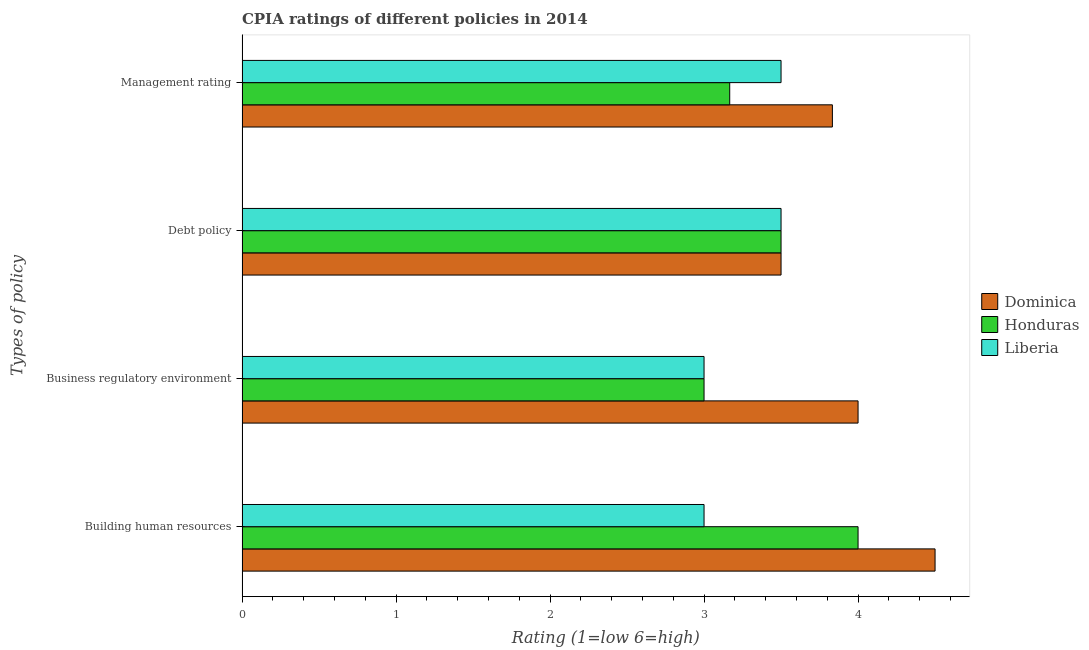Are the number of bars per tick equal to the number of legend labels?
Provide a short and direct response. Yes. Are the number of bars on each tick of the Y-axis equal?
Your answer should be compact. Yes. How many bars are there on the 4th tick from the top?
Your answer should be compact. 3. What is the label of the 1st group of bars from the top?
Offer a terse response. Management rating. Across all countries, what is the minimum cpia rating of management?
Keep it short and to the point. 3.17. In which country was the cpia rating of debt policy maximum?
Make the answer very short. Dominica. In which country was the cpia rating of building human resources minimum?
Provide a succinct answer. Liberia. What is the total cpia rating of building human resources in the graph?
Offer a very short reply. 11.5. What is the average cpia rating of business regulatory environment per country?
Your answer should be very brief. 3.33. What is the difference between the cpia rating of debt policy and cpia rating of business regulatory environment in Honduras?
Give a very brief answer. 0.5. Is the cpia rating of management in Dominica less than that in Honduras?
Keep it short and to the point. No. Is the difference between the cpia rating of building human resources in Dominica and Liberia greater than the difference between the cpia rating of business regulatory environment in Dominica and Liberia?
Provide a short and direct response. Yes. What is the difference between the highest and the lowest cpia rating of debt policy?
Offer a very short reply. 0. In how many countries, is the cpia rating of debt policy greater than the average cpia rating of debt policy taken over all countries?
Provide a succinct answer. 0. What does the 1st bar from the top in Debt policy represents?
Provide a succinct answer. Liberia. What does the 1st bar from the bottom in Business regulatory environment represents?
Ensure brevity in your answer.  Dominica. Is it the case that in every country, the sum of the cpia rating of building human resources and cpia rating of business regulatory environment is greater than the cpia rating of debt policy?
Offer a very short reply. Yes. How many bars are there?
Keep it short and to the point. 12. How many countries are there in the graph?
Offer a terse response. 3. What is the difference between two consecutive major ticks on the X-axis?
Give a very brief answer. 1. Are the values on the major ticks of X-axis written in scientific E-notation?
Your answer should be compact. No. Where does the legend appear in the graph?
Offer a very short reply. Center right. How are the legend labels stacked?
Offer a very short reply. Vertical. What is the title of the graph?
Your answer should be compact. CPIA ratings of different policies in 2014. Does "Angola" appear as one of the legend labels in the graph?
Keep it short and to the point. No. What is the label or title of the X-axis?
Provide a short and direct response. Rating (1=low 6=high). What is the label or title of the Y-axis?
Offer a very short reply. Types of policy. What is the Rating (1=low 6=high) of Honduras in Building human resources?
Provide a succinct answer. 4. What is the Rating (1=low 6=high) in Liberia in Building human resources?
Your answer should be compact. 3. What is the Rating (1=low 6=high) of Dominica in Business regulatory environment?
Keep it short and to the point. 4. What is the Rating (1=low 6=high) of Honduras in Business regulatory environment?
Give a very brief answer. 3. What is the Rating (1=low 6=high) in Dominica in Debt policy?
Offer a terse response. 3.5. What is the Rating (1=low 6=high) of Liberia in Debt policy?
Your response must be concise. 3.5. What is the Rating (1=low 6=high) in Dominica in Management rating?
Offer a terse response. 3.83. What is the Rating (1=low 6=high) of Honduras in Management rating?
Your answer should be very brief. 3.17. What is the Rating (1=low 6=high) in Liberia in Management rating?
Keep it short and to the point. 3.5. Across all Types of policy, what is the maximum Rating (1=low 6=high) in Dominica?
Offer a very short reply. 4.5. Across all Types of policy, what is the minimum Rating (1=low 6=high) of Liberia?
Give a very brief answer. 3. What is the total Rating (1=low 6=high) of Dominica in the graph?
Provide a short and direct response. 15.83. What is the total Rating (1=low 6=high) of Honduras in the graph?
Offer a terse response. 13.67. What is the difference between the Rating (1=low 6=high) in Honduras in Building human resources and that in Business regulatory environment?
Give a very brief answer. 1. What is the difference between the Rating (1=low 6=high) of Dominica in Building human resources and that in Debt policy?
Provide a short and direct response. 1. What is the difference between the Rating (1=low 6=high) in Honduras in Building human resources and that in Debt policy?
Give a very brief answer. 0.5. What is the difference between the Rating (1=low 6=high) of Honduras in Building human resources and that in Management rating?
Ensure brevity in your answer.  0.83. What is the difference between the Rating (1=low 6=high) of Liberia in Building human resources and that in Management rating?
Make the answer very short. -0.5. What is the difference between the Rating (1=low 6=high) of Dominica in Business regulatory environment and that in Debt policy?
Your answer should be very brief. 0.5. What is the difference between the Rating (1=low 6=high) of Honduras in Business regulatory environment and that in Debt policy?
Offer a terse response. -0.5. What is the difference between the Rating (1=low 6=high) in Dominica in Business regulatory environment and that in Management rating?
Give a very brief answer. 0.17. What is the difference between the Rating (1=low 6=high) of Honduras in Business regulatory environment and that in Management rating?
Provide a short and direct response. -0.17. What is the difference between the Rating (1=low 6=high) of Dominica in Building human resources and the Rating (1=low 6=high) of Honduras in Business regulatory environment?
Your answer should be compact. 1.5. What is the difference between the Rating (1=low 6=high) of Dominica in Building human resources and the Rating (1=low 6=high) of Liberia in Business regulatory environment?
Your answer should be compact. 1.5. What is the difference between the Rating (1=low 6=high) in Dominica in Building human resources and the Rating (1=low 6=high) in Honduras in Debt policy?
Offer a terse response. 1. What is the difference between the Rating (1=low 6=high) in Dominica in Building human resources and the Rating (1=low 6=high) in Liberia in Debt policy?
Keep it short and to the point. 1. What is the difference between the Rating (1=low 6=high) in Honduras in Building human resources and the Rating (1=low 6=high) in Liberia in Management rating?
Offer a terse response. 0.5. What is the difference between the Rating (1=low 6=high) of Dominica in Business regulatory environment and the Rating (1=low 6=high) of Liberia in Debt policy?
Ensure brevity in your answer.  0.5. What is the difference between the Rating (1=low 6=high) of Honduras in Business regulatory environment and the Rating (1=low 6=high) of Liberia in Debt policy?
Make the answer very short. -0.5. What is the difference between the Rating (1=low 6=high) of Dominica in Business regulatory environment and the Rating (1=low 6=high) of Honduras in Management rating?
Offer a very short reply. 0.83. What is the difference between the Rating (1=low 6=high) in Honduras in Business regulatory environment and the Rating (1=low 6=high) in Liberia in Management rating?
Offer a very short reply. -0.5. What is the difference between the Rating (1=low 6=high) of Dominica in Debt policy and the Rating (1=low 6=high) of Honduras in Management rating?
Keep it short and to the point. 0.33. What is the average Rating (1=low 6=high) in Dominica per Types of policy?
Give a very brief answer. 3.96. What is the average Rating (1=low 6=high) of Honduras per Types of policy?
Make the answer very short. 3.42. What is the average Rating (1=low 6=high) in Liberia per Types of policy?
Keep it short and to the point. 3.25. What is the difference between the Rating (1=low 6=high) of Dominica and Rating (1=low 6=high) of Honduras in Building human resources?
Keep it short and to the point. 0.5. What is the difference between the Rating (1=low 6=high) of Honduras and Rating (1=low 6=high) of Liberia in Building human resources?
Make the answer very short. 1. What is the difference between the Rating (1=low 6=high) in Dominica and Rating (1=low 6=high) in Liberia in Debt policy?
Offer a terse response. 0. What is the difference between the Rating (1=low 6=high) in Dominica and Rating (1=low 6=high) in Liberia in Management rating?
Keep it short and to the point. 0.33. What is the ratio of the Rating (1=low 6=high) of Dominica in Building human resources to that in Debt policy?
Keep it short and to the point. 1.29. What is the ratio of the Rating (1=low 6=high) of Honduras in Building human resources to that in Debt policy?
Ensure brevity in your answer.  1.14. What is the ratio of the Rating (1=low 6=high) in Dominica in Building human resources to that in Management rating?
Ensure brevity in your answer.  1.17. What is the ratio of the Rating (1=low 6=high) in Honduras in Building human resources to that in Management rating?
Ensure brevity in your answer.  1.26. What is the ratio of the Rating (1=low 6=high) of Dominica in Business regulatory environment to that in Debt policy?
Make the answer very short. 1.14. What is the ratio of the Rating (1=low 6=high) of Honduras in Business regulatory environment to that in Debt policy?
Offer a very short reply. 0.86. What is the ratio of the Rating (1=low 6=high) in Liberia in Business regulatory environment to that in Debt policy?
Your answer should be very brief. 0.86. What is the ratio of the Rating (1=low 6=high) in Dominica in Business regulatory environment to that in Management rating?
Ensure brevity in your answer.  1.04. What is the ratio of the Rating (1=low 6=high) in Dominica in Debt policy to that in Management rating?
Give a very brief answer. 0.91. What is the ratio of the Rating (1=low 6=high) in Honduras in Debt policy to that in Management rating?
Offer a very short reply. 1.11. What is the difference between the highest and the second highest Rating (1=low 6=high) in Dominica?
Your answer should be compact. 0.5. What is the difference between the highest and the second highest Rating (1=low 6=high) in Honduras?
Provide a short and direct response. 0.5. What is the difference between the highest and the second highest Rating (1=low 6=high) in Liberia?
Provide a succinct answer. 0. What is the difference between the highest and the lowest Rating (1=low 6=high) in Liberia?
Your answer should be very brief. 0.5. 